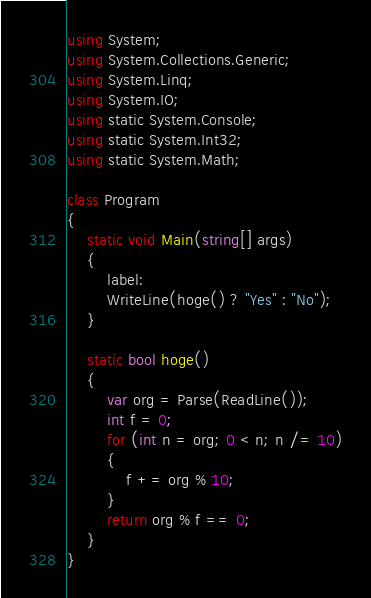Convert code to text. <code><loc_0><loc_0><loc_500><loc_500><_C#_>using System;
using System.Collections.Generic;
using System.Linq;
using System.IO;
using static System.Console;
using static System.Int32;
using static System.Math;
 
class Program
{
    static void Main(string[] args)
    {
        label:
        WriteLine(hoge() ? "Yes" : "No");
    }

    static bool hoge()
    {
        var org = Parse(ReadLine());
        int f = 0;
        for (int n = org; 0 < n; n /= 10)
        {
            f += org % 10;
        }
        return org % f == 0;
    }
}
</code> 